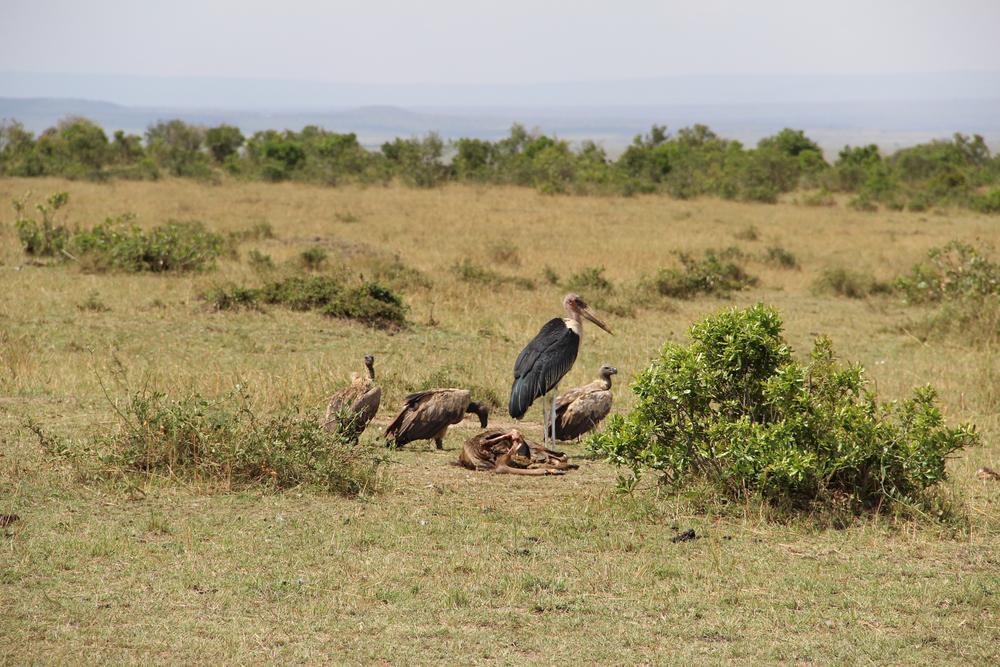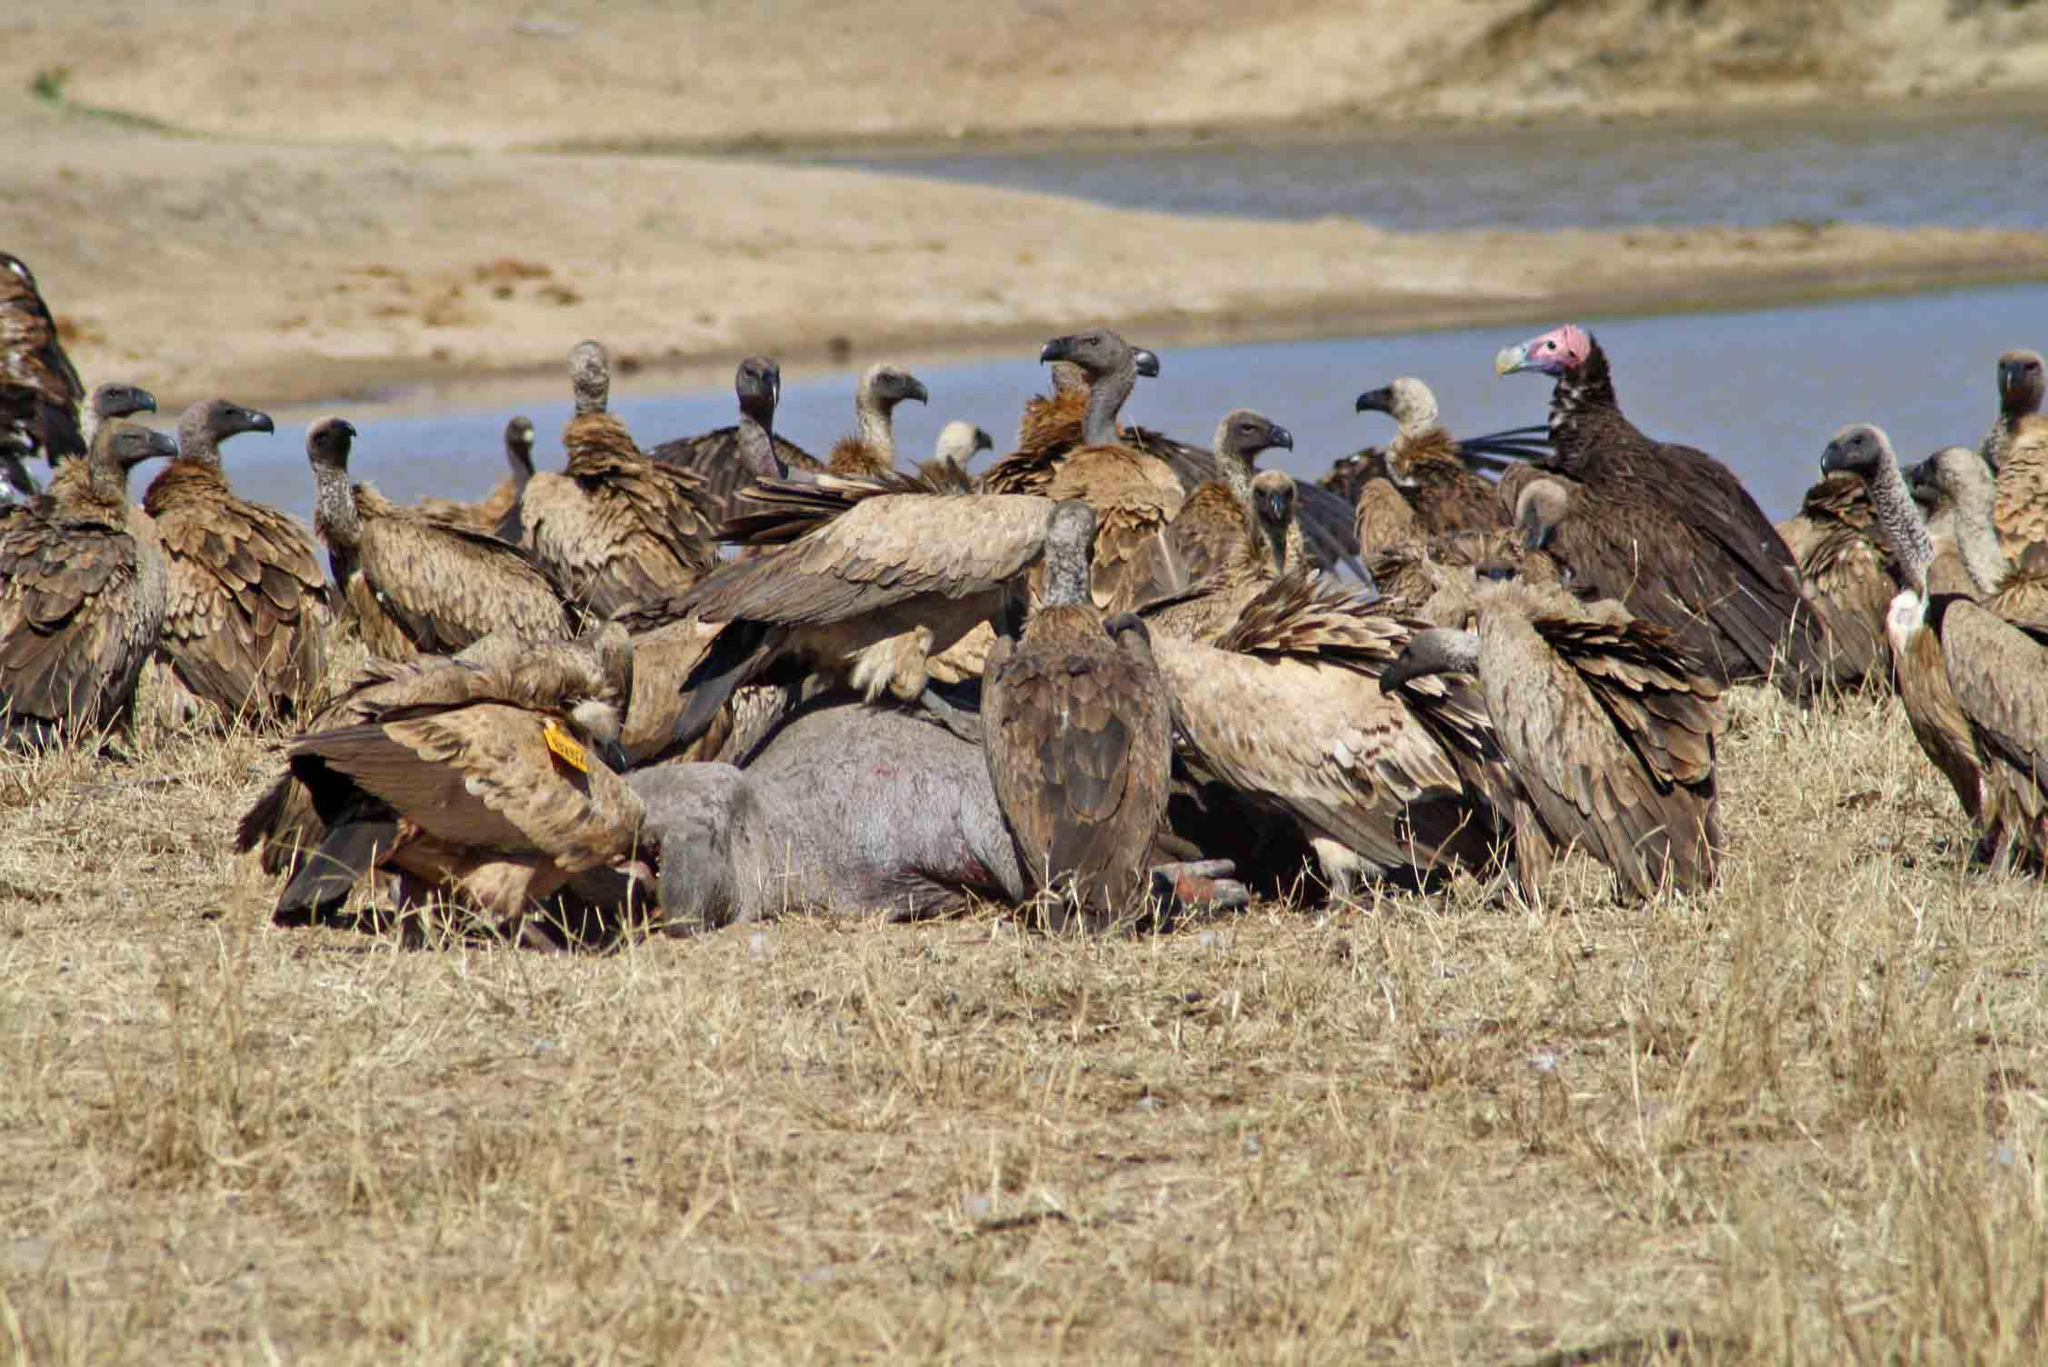The first image is the image on the left, the second image is the image on the right. Examine the images to the left and right. Is the description "The sky can be seen in the image on the left" accurate? Answer yes or no. Yes. The first image is the image on the left, the second image is the image on the right. Examine the images to the left and right. Is the description "A body of water is visible in one of the images." accurate? Answer yes or no. Yes. The first image is the image on the left, the second image is the image on the right. For the images shown, is this caption "there is water in the image on the right" true? Answer yes or no. Yes. The first image is the image on the left, the second image is the image on the right. Evaluate the accuracy of this statement regarding the images: "An image features no more than four birds gathered around a carcass.". Is it true? Answer yes or no. Yes. 